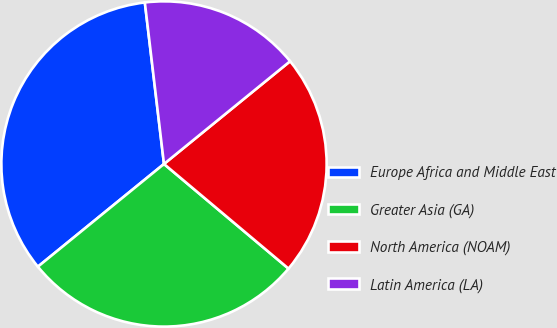<chart> <loc_0><loc_0><loc_500><loc_500><pie_chart><fcel>Europe Africa and Middle East<fcel>Greater Asia (GA)<fcel>North America (NOAM)<fcel>Latin America (LA)<nl><fcel>34.0%<fcel>28.0%<fcel>22.0%<fcel>16.0%<nl></chart> 